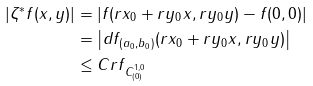Convert formula to latex. <formula><loc_0><loc_0><loc_500><loc_500>| \zeta ^ { * } f ( x , y ) | & = | f ( r x _ { 0 } + r y _ { 0 } x , r y _ { 0 } y ) - f ( 0 , 0 ) | \\ & = \left | d f _ { ( a _ { 0 } , b _ { 0 } ) } ( r x _ { 0 } + r y _ { 0 } x , r y _ { 0 } y ) \right | \\ & \leq C r \| f \| _ { C ^ { 1 , 0 } _ { ( 0 ) } }</formula> 